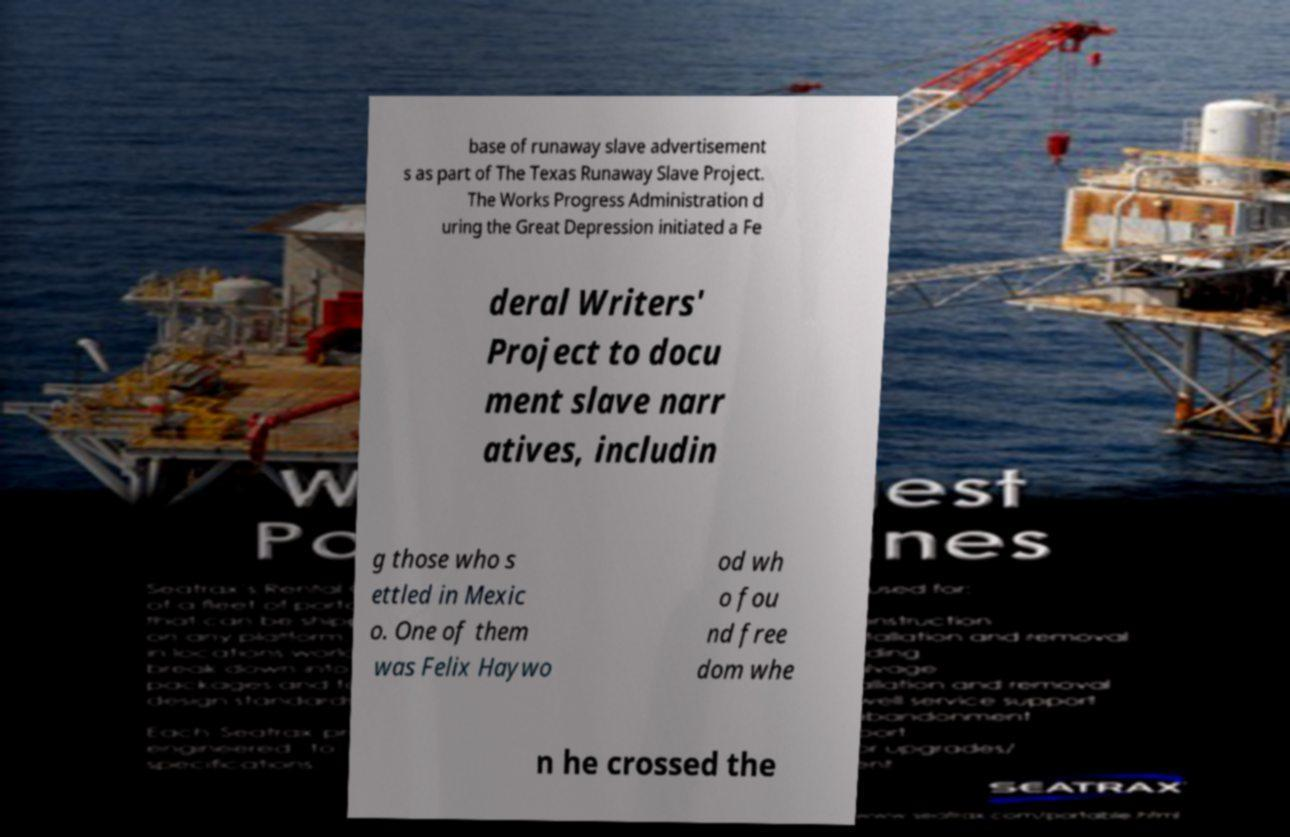Could you assist in decoding the text presented in this image and type it out clearly? base of runaway slave advertisement s as part of The Texas Runaway Slave Project. The Works Progress Administration d uring the Great Depression initiated a Fe deral Writers' Project to docu ment slave narr atives, includin g those who s ettled in Mexic o. One of them was Felix Haywo od wh o fou nd free dom whe n he crossed the 